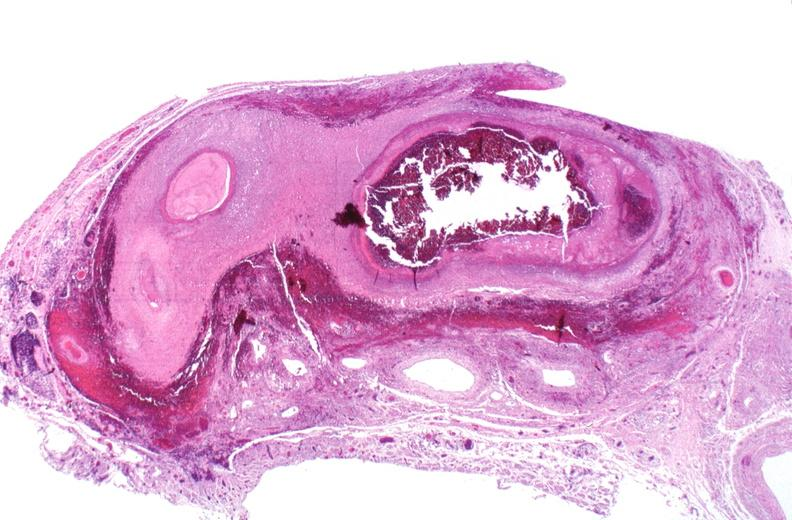s marfans syndrome present?
Answer the question using a single word or phrase. No 